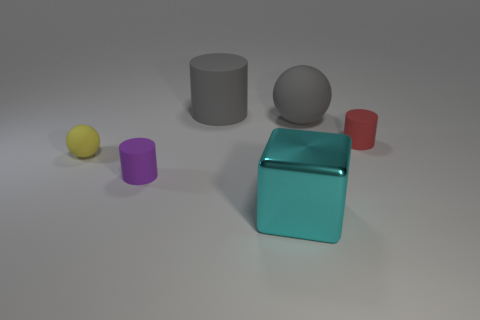There is a ball that is the same size as the metallic thing; what is its material?
Offer a terse response. Rubber. What number of other things are made of the same material as the red thing?
Your answer should be very brief. 4. There is a gray sphere; is it the same size as the matte ball that is left of the tiny purple cylinder?
Offer a terse response. No. Are there fewer small yellow matte objects that are to the right of the gray cylinder than small things on the right side of the big cyan metal block?
Give a very brief answer. Yes. What is the size of the rubber ball that is to the right of the tiny yellow rubber sphere?
Your response must be concise. Large. Does the yellow rubber sphere have the same size as the cyan thing?
Keep it short and to the point. No. What number of matte things are both to the right of the small purple cylinder and on the left side of the tiny red object?
Offer a terse response. 2. How many red things are large metal objects or cylinders?
Your answer should be compact. 1. How many rubber things are either big blue objects or large blocks?
Your response must be concise. 0. Are any large matte things visible?
Your response must be concise. Yes. 